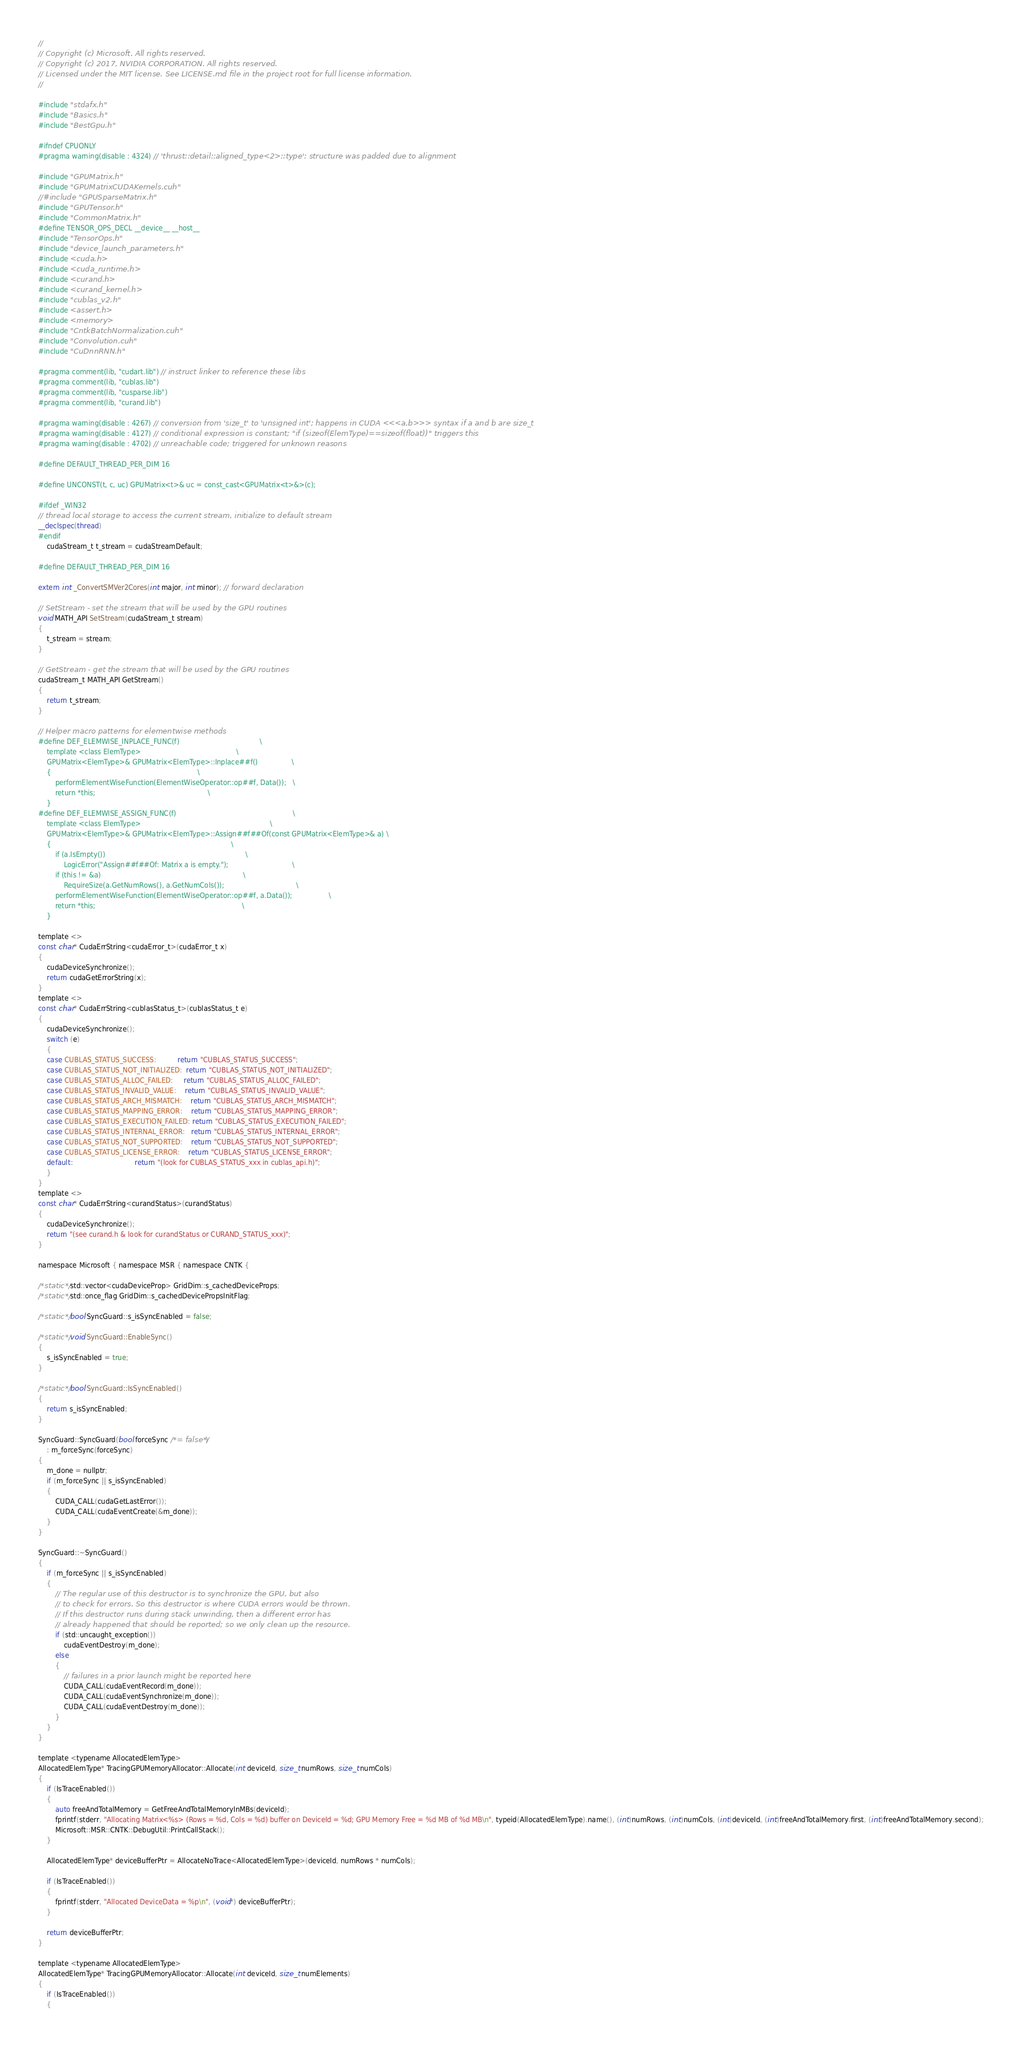Convert code to text. <code><loc_0><loc_0><loc_500><loc_500><_Cuda_>//
// Copyright (c) Microsoft. All rights reserved.
// Copyright (c) 2017, NVIDIA CORPORATION. All rights reserved.
// Licensed under the MIT license. See LICENSE.md file in the project root for full license information.
//

#include "stdafx.h"
#include "Basics.h"
#include "BestGpu.h"

#ifndef CPUONLY
#pragma warning(disable : 4324) // 'thrust::detail::aligned_type<2>::type': structure was padded due to alignment

#include "GPUMatrix.h"
#include "GPUMatrixCUDAKernels.cuh"
//#include "GPUSparseMatrix.h"
#include "GPUTensor.h"
#include "CommonMatrix.h"
#define TENSOR_OPS_DECL __device__ __host__
#include "TensorOps.h"
#include "device_launch_parameters.h"
#include <cuda.h>
#include <cuda_runtime.h>
#include <curand.h>
#include <curand_kernel.h>
#include "cublas_v2.h"
#include <assert.h>
#include <memory>
#include "CntkBatchNormalization.cuh"
#include "Convolution.cuh"
#include "CuDnnRNN.h"

#pragma comment(lib, "cudart.lib") // instruct linker to reference these libs
#pragma comment(lib, "cublas.lib")
#pragma comment(lib, "cusparse.lib")
#pragma comment(lib, "curand.lib")

#pragma warning(disable : 4267) // conversion from 'size_t' to 'unsigned int'; happens in CUDA <<<a,b>>> syntax if a and b are size_t
#pragma warning(disable : 4127) // conditional expression is constant; "if (sizeof(ElemType)==sizeof(float))" triggers this
#pragma warning(disable : 4702) // unreachable code; triggered for unknown reasons

#define DEFAULT_THREAD_PER_DIM 16

#define UNCONST(t, c, uc) GPUMatrix<t>& uc = const_cast<GPUMatrix<t>&>(c);

#ifdef _WIN32
// thread local storage to access the current stream, initialize to default stream
__declspec(thread)
#endif
    cudaStream_t t_stream = cudaStreamDefault;

#define DEFAULT_THREAD_PER_DIM 16

extern int _ConvertSMVer2Cores(int major, int minor); // forward declaration

// SetStream - set the stream that will be used by the GPU routines
void MATH_API SetStream(cudaStream_t stream)
{
    t_stream = stream;
}

// GetStream - get the stream that will be used by the GPU routines
cudaStream_t MATH_API GetStream()
{
    return t_stream;
}

// Helper macro patterns for elementwise methods
#define DEF_ELEMWISE_INPLACE_FUNC(f)                                      \
    template <class ElemType>                                             \
    GPUMatrix<ElemType>& GPUMatrix<ElemType>::Inplace##f()                \
    {                                                                     \
        performElementWiseFunction(ElementWiseOperator::op##f, Data());   \
        return *this;                                                     \
    }
#define DEF_ELEMWISE_ASSIGN_FUNC(f)                                                       \
    template <class ElemType>                                                             \
    GPUMatrix<ElemType>& GPUMatrix<ElemType>::Assign##f##Of(const GPUMatrix<ElemType>& a) \
    {                                                                                     \
        if (a.IsEmpty())                                                                  \
            LogicError("Assign##f##Of: Matrix a is empty.");                              \
        if (this != &a)                                                                   \
            RequireSize(a.GetNumRows(), a.GetNumCols());                                  \
        performElementWiseFunction(ElementWiseOperator::op##f, a.Data());                 \
        return *this;                                                                     \
    }

template <>
const char* CudaErrString<cudaError_t>(cudaError_t x)
{
    cudaDeviceSynchronize();
    return cudaGetErrorString(x);
}
template <>
const char* CudaErrString<cublasStatus_t>(cublasStatus_t e)
{
    cudaDeviceSynchronize();
    switch (e)
    {
    case CUBLAS_STATUS_SUCCESS:          return "CUBLAS_STATUS_SUCCESS";
    case CUBLAS_STATUS_NOT_INITIALIZED:  return "CUBLAS_STATUS_NOT_INITIALIZED";
    case CUBLAS_STATUS_ALLOC_FAILED:     return "CUBLAS_STATUS_ALLOC_FAILED";
    case CUBLAS_STATUS_INVALID_VALUE:    return "CUBLAS_STATUS_INVALID_VALUE";
    case CUBLAS_STATUS_ARCH_MISMATCH:    return "CUBLAS_STATUS_ARCH_MISMATCH";
    case CUBLAS_STATUS_MAPPING_ERROR:    return "CUBLAS_STATUS_MAPPING_ERROR";
    case CUBLAS_STATUS_EXECUTION_FAILED: return "CUBLAS_STATUS_EXECUTION_FAILED";
    case CUBLAS_STATUS_INTERNAL_ERROR:   return "CUBLAS_STATUS_INTERNAL_ERROR";
    case CUBLAS_STATUS_NOT_SUPPORTED:    return "CUBLAS_STATUS_NOT_SUPPORTED";
    case CUBLAS_STATUS_LICENSE_ERROR:    return "CUBLAS_STATUS_LICENSE_ERROR";
    default:                             return "(look for CUBLAS_STATUS_xxx in cublas_api.h)";
    }
}
template <>
const char* CudaErrString<curandStatus>(curandStatus)
{
    cudaDeviceSynchronize();
    return "(see curand.h & look for curandStatus or CURAND_STATUS_xxx)";
}

namespace Microsoft { namespace MSR { namespace CNTK {

/*static*/ std::vector<cudaDeviceProp> GridDim::s_cachedDeviceProps;
/*static*/ std::once_flag GridDim::s_cachedDevicePropsInitFlag;

/*static*/ bool SyncGuard::s_isSyncEnabled = false;

/*static*/ void SyncGuard::EnableSync()
{
    s_isSyncEnabled = true;
}

/*static*/ bool SyncGuard::IsSyncEnabled()
{
    return s_isSyncEnabled;
}

SyncGuard::SyncGuard(bool forceSync /*= false*/)
    : m_forceSync(forceSync)
{
    m_done = nullptr;
    if (m_forceSync || s_isSyncEnabled)
    {
        CUDA_CALL(cudaGetLastError());
        CUDA_CALL(cudaEventCreate(&m_done));
    }
}

SyncGuard::~SyncGuard()
{
    if (m_forceSync || s_isSyncEnabled)
    {
        // The regular use of this destructor is to synchronize the GPU, but also
        // to check for errors. So this destructor is where CUDA errors would be thrown.
        // If this destructor runs during stack unwinding, then a different error has
        // already happened that should be reported; so we only clean up the resource.
        if (std::uncaught_exception())
            cudaEventDestroy(m_done);
        else
        {
            // failures in a prior launch might be reported here
            CUDA_CALL(cudaEventRecord(m_done));
            CUDA_CALL(cudaEventSynchronize(m_done));
            CUDA_CALL(cudaEventDestroy(m_done));
        }
    }
}

template <typename AllocatedElemType>
AllocatedElemType* TracingGPUMemoryAllocator::Allocate(int deviceId, size_t numRows, size_t numCols)
{
    if (IsTraceEnabled())
    {
        auto freeAndTotalMemory = GetFreeAndTotalMemoryInMBs(deviceId);
        fprintf(stderr, "Allocating Matrix<%s> (Rows = %d, Cols = %d) buffer on DeviceId = %d; GPU Memory Free = %d MB of %d MB\n", typeid(AllocatedElemType).name(), (int)numRows, (int)numCols, (int)deviceId, (int)freeAndTotalMemory.first, (int)freeAndTotalMemory.second);
        Microsoft::MSR::CNTK::DebugUtil::PrintCallStack();
    }

    AllocatedElemType* deviceBufferPtr = AllocateNoTrace<AllocatedElemType>(deviceId, numRows * numCols);

    if (IsTraceEnabled())
    {
        fprintf(stderr, "Allocated DeviceData = %p\n", (void*) deviceBufferPtr);
    }

    return deviceBufferPtr;
}

template <typename AllocatedElemType>
AllocatedElemType* TracingGPUMemoryAllocator::Allocate(int deviceId, size_t numElements)
{
    if (IsTraceEnabled())
    {</code> 